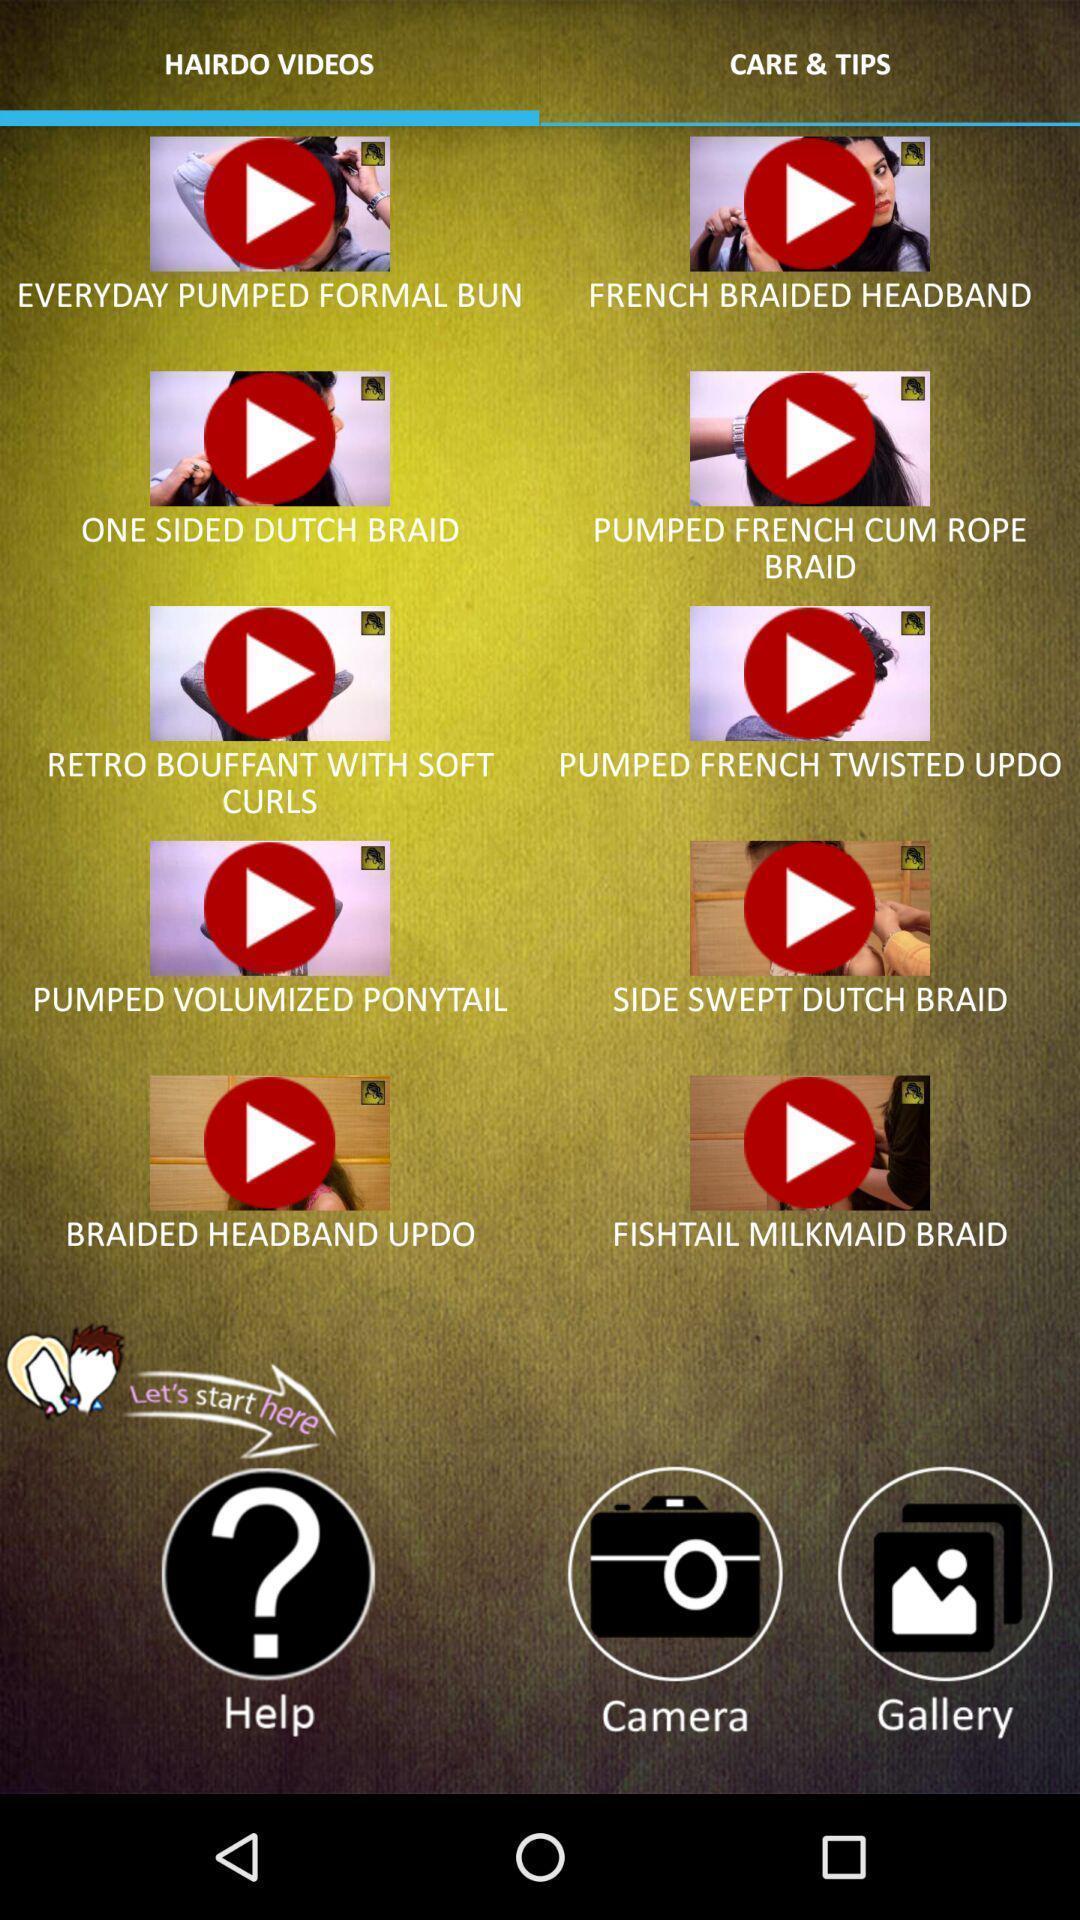Explain the elements present in this screenshot. Screen displaying the video thumbnails. 